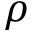Convert formula to latex. <formula><loc_0><loc_0><loc_500><loc_500>\rho</formula> 